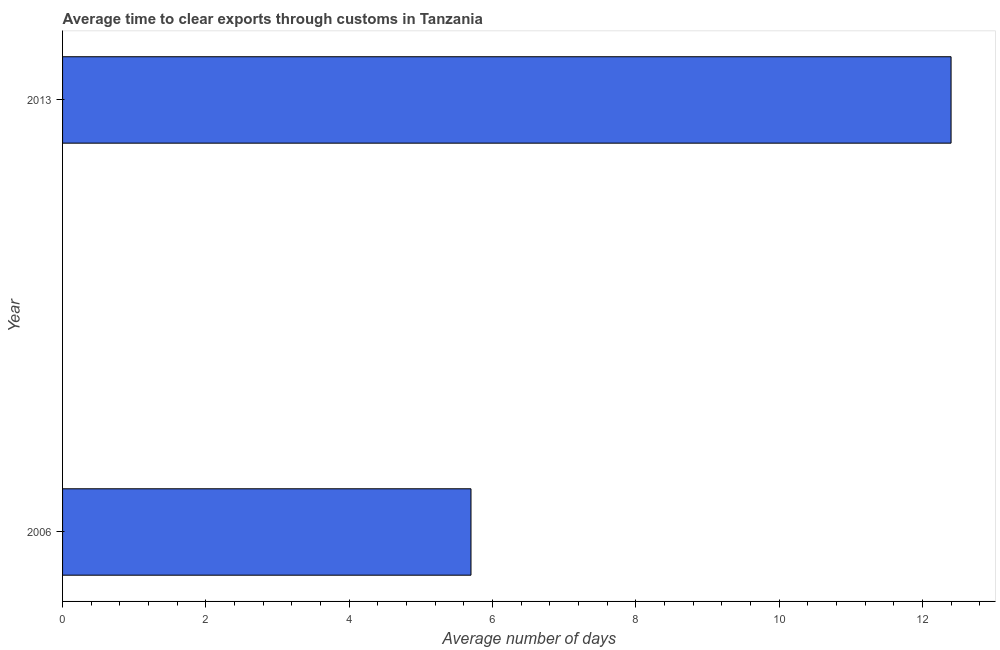Does the graph contain grids?
Your answer should be compact. No. What is the title of the graph?
Your answer should be compact. Average time to clear exports through customs in Tanzania. What is the label or title of the X-axis?
Your answer should be very brief. Average number of days. Across all years, what is the maximum time to clear exports through customs?
Your answer should be compact. 12.4. Across all years, what is the minimum time to clear exports through customs?
Ensure brevity in your answer.  5.7. In which year was the time to clear exports through customs maximum?
Give a very brief answer. 2013. What is the sum of the time to clear exports through customs?
Keep it short and to the point. 18.1. What is the difference between the time to clear exports through customs in 2006 and 2013?
Offer a very short reply. -6.7. What is the average time to clear exports through customs per year?
Offer a terse response. 9.05. What is the median time to clear exports through customs?
Provide a short and direct response. 9.05. What is the ratio of the time to clear exports through customs in 2006 to that in 2013?
Offer a terse response. 0.46. Are all the bars in the graph horizontal?
Your answer should be very brief. Yes. What is the ratio of the Average number of days in 2006 to that in 2013?
Your answer should be very brief. 0.46. 